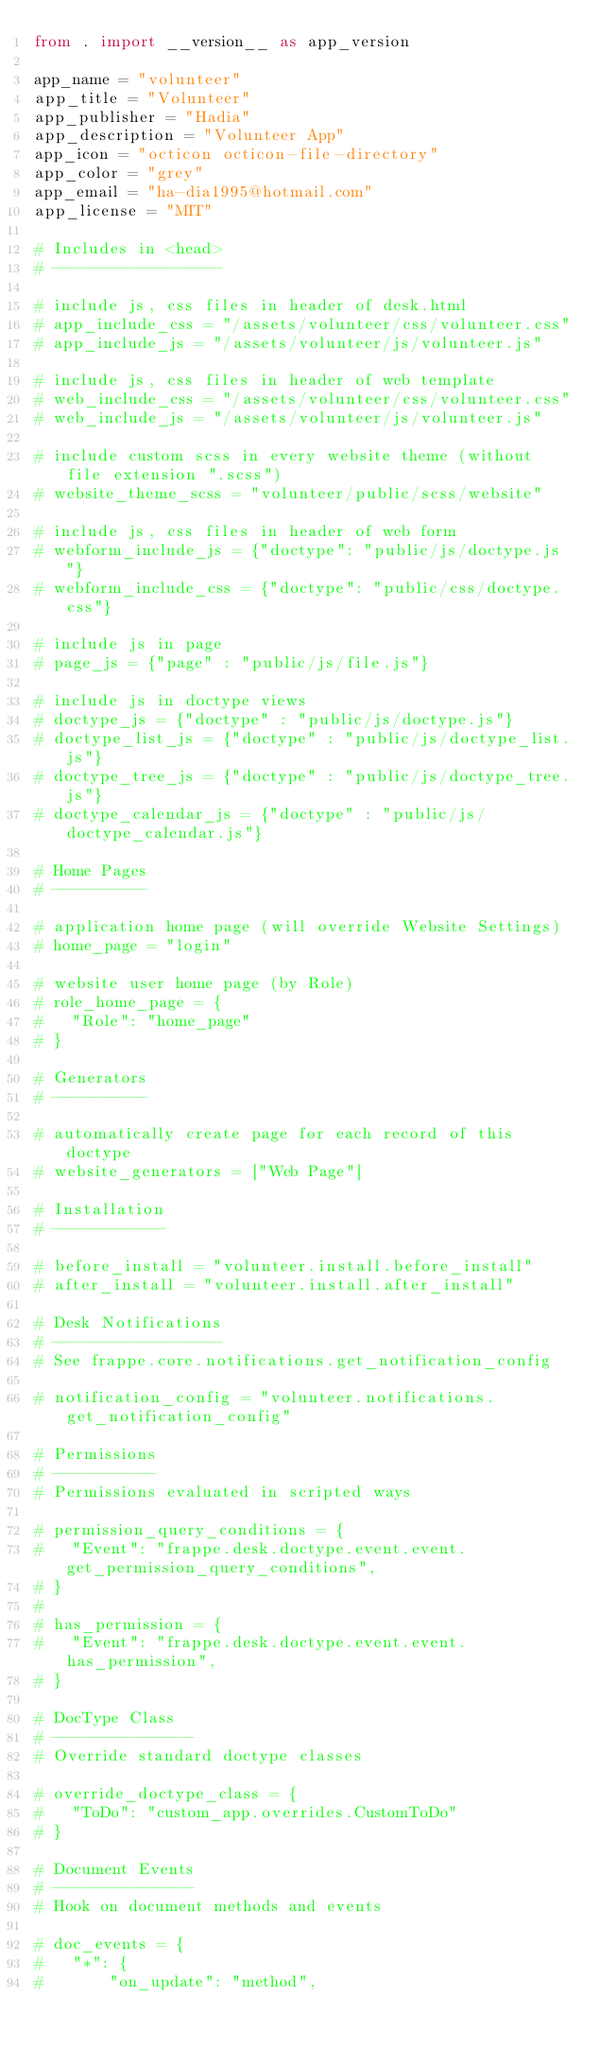<code> <loc_0><loc_0><loc_500><loc_500><_Python_>from . import __version__ as app_version

app_name = "volunteer"
app_title = "Volunteer"
app_publisher = "Hadia"
app_description = "Volunteer App"
app_icon = "octicon octicon-file-directory"
app_color = "grey"
app_email = "ha-dia1995@hotmail.com"
app_license = "MIT"

# Includes in <head>
# ------------------

# include js, css files in header of desk.html
# app_include_css = "/assets/volunteer/css/volunteer.css"
# app_include_js = "/assets/volunteer/js/volunteer.js"

# include js, css files in header of web template
# web_include_css = "/assets/volunteer/css/volunteer.css"
# web_include_js = "/assets/volunteer/js/volunteer.js"

# include custom scss in every website theme (without file extension ".scss")
# website_theme_scss = "volunteer/public/scss/website"

# include js, css files in header of web form
# webform_include_js = {"doctype": "public/js/doctype.js"}
# webform_include_css = {"doctype": "public/css/doctype.css"}

# include js in page
# page_js = {"page" : "public/js/file.js"}

# include js in doctype views
# doctype_js = {"doctype" : "public/js/doctype.js"}
# doctype_list_js = {"doctype" : "public/js/doctype_list.js"}
# doctype_tree_js = {"doctype" : "public/js/doctype_tree.js"}
# doctype_calendar_js = {"doctype" : "public/js/doctype_calendar.js"}

# Home Pages
# ----------

# application home page (will override Website Settings)
# home_page = "login"

# website user home page (by Role)
# role_home_page = {
#	"Role": "home_page"
# }

# Generators
# ----------

# automatically create page for each record of this doctype
# website_generators = ["Web Page"]

# Installation
# ------------

# before_install = "volunteer.install.before_install"
# after_install = "volunteer.install.after_install"

# Desk Notifications
# ------------------
# See frappe.core.notifications.get_notification_config

# notification_config = "volunteer.notifications.get_notification_config"

# Permissions
# -----------
# Permissions evaluated in scripted ways

# permission_query_conditions = {
# 	"Event": "frappe.desk.doctype.event.event.get_permission_query_conditions",
# }
#
# has_permission = {
# 	"Event": "frappe.desk.doctype.event.event.has_permission",
# }

# DocType Class
# ---------------
# Override standard doctype classes

# override_doctype_class = {
# 	"ToDo": "custom_app.overrides.CustomToDo"
# }

# Document Events
# ---------------
# Hook on document methods and events

# doc_events = {
# 	"*": {
# 		"on_update": "method",</code> 